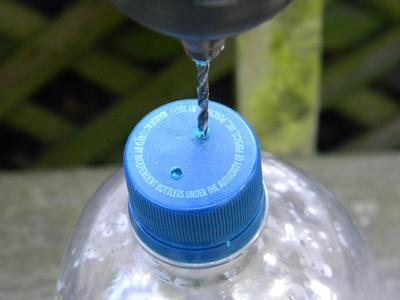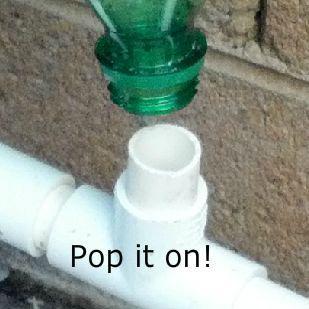The first image is the image on the left, the second image is the image on the right. Examine the images to the left and right. Is the description "At least one plastic bottle has been cut in half." accurate? Answer yes or no. No. The first image is the image on the left, the second image is the image on the right. Assess this claim about the two images: "Human hands are visible holding soda bottles in at least one image.". Correct or not? Answer yes or no. No. 